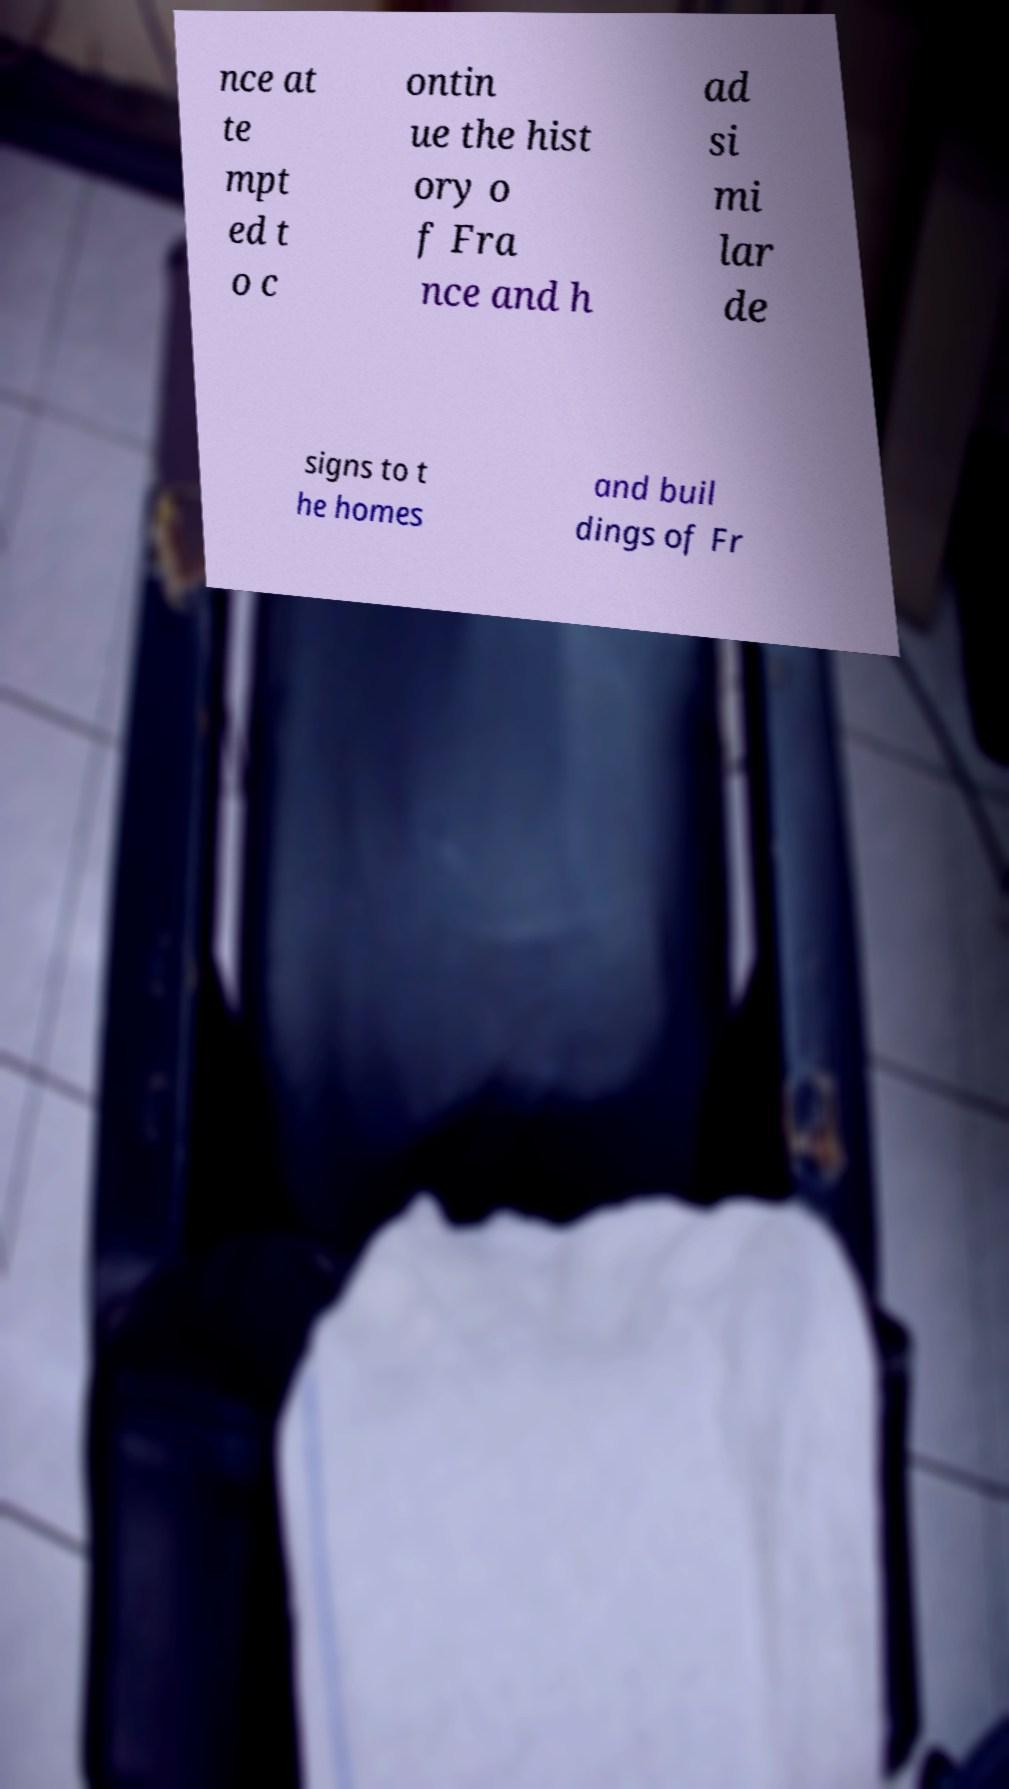Please read and relay the text visible in this image. What does it say? nce at te mpt ed t o c ontin ue the hist ory o f Fra nce and h ad si mi lar de signs to t he homes and buil dings of Fr 